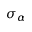<formula> <loc_0><loc_0><loc_500><loc_500>\sigma _ { \alpha }</formula> 